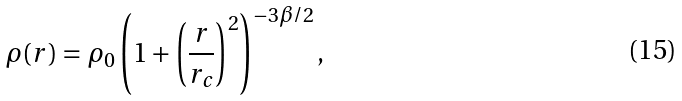Convert formula to latex. <formula><loc_0><loc_0><loc_500><loc_500>\rho ( r ) = \rho _ { 0 } \left ( 1 + \left ( \frac { r } { r _ { c } } \right ) ^ { 2 } \right ) ^ { - 3 \beta / 2 } ,</formula> 